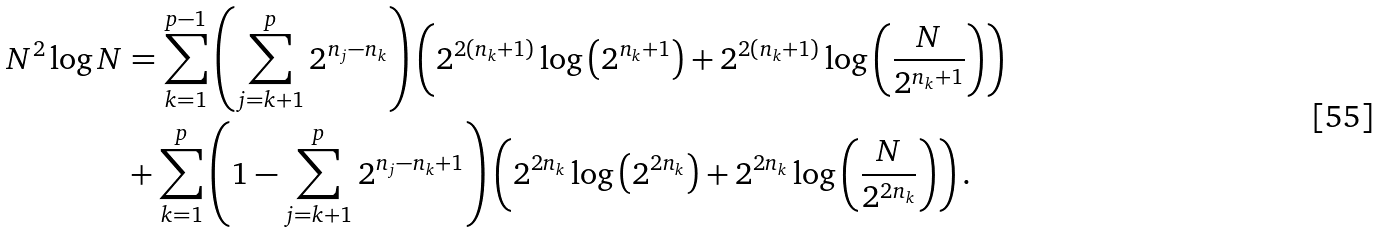<formula> <loc_0><loc_0><loc_500><loc_500>N ^ { 2 } \log N & = \sum _ { k = 1 } ^ { p - 1 } \left ( \sum _ { j = k + 1 } ^ { p } 2 ^ { n _ { j } - n _ { k } } \right ) \left ( 2 ^ { 2 ( n _ { k } + 1 ) } \log \left ( 2 ^ { n _ { k } + 1 } \right ) + 2 ^ { 2 ( n _ { k } + 1 ) } \log \left ( \frac { N } { 2 ^ { n _ { k } + 1 } } \right ) \right ) \\ & + \sum _ { k = 1 } ^ { p } \left ( 1 - \sum _ { j = k + 1 } ^ { p } 2 ^ { n _ { j } - n _ { k } + 1 } \right ) \left ( 2 ^ { 2 n _ { k } } \log \left ( 2 ^ { 2 n _ { k } } \right ) + 2 ^ { 2 n _ { k } } \log \left ( \frac { N } { 2 ^ { 2 n _ { k } } } \right ) \right ) .</formula> 